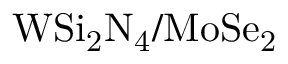Convert formula to latex. <formula><loc_0><loc_0><loc_500><loc_500>W S i _ { 2 } N _ { 4 } / M o S e _ { 2 }</formula> 